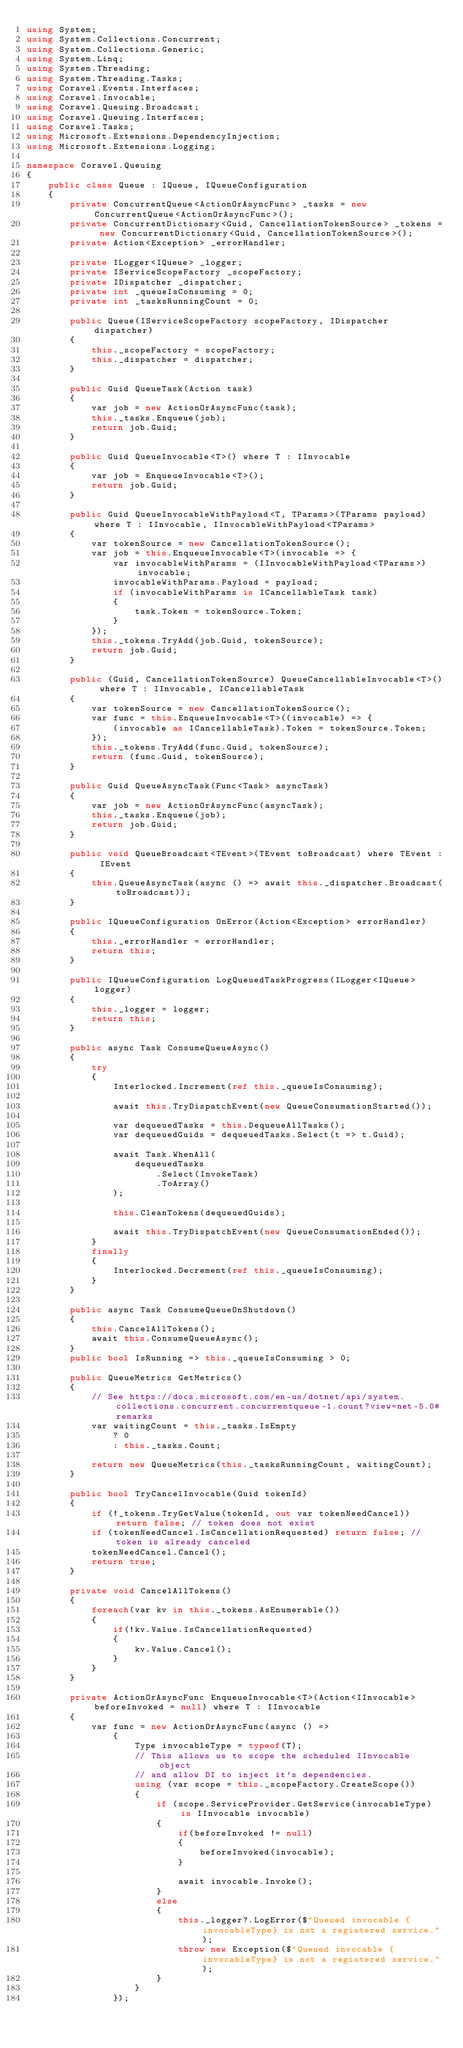Convert code to text. <code><loc_0><loc_0><loc_500><loc_500><_C#_>using System;
using System.Collections.Concurrent;
using System.Collections.Generic;
using System.Linq;
using System.Threading;
using System.Threading.Tasks;
using Coravel.Events.Interfaces;
using Coravel.Invocable;
using Coravel.Queuing.Broadcast;
using Coravel.Queuing.Interfaces;
using Coravel.Tasks;
using Microsoft.Extensions.DependencyInjection;
using Microsoft.Extensions.Logging;

namespace Coravel.Queuing
{
    public class Queue : IQueue, IQueueConfiguration
    {
        private ConcurrentQueue<ActionOrAsyncFunc> _tasks = new ConcurrentQueue<ActionOrAsyncFunc>();
        private ConcurrentDictionary<Guid, CancellationTokenSource> _tokens = new ConcurrentDictionary<Guid, CancellationTokenSource>();
        private Action<Exception> _errorHandler;

        private ILogger<IQueue> _logger;
        private IServiceScopeFactory _scopeFactory;
        private IDispatcher _dispatcher;
        private int _queueIsConsuming = 0;
        private int _tasksRunningCount = 0;

        public Queue(IServiceScopeFactory scopeFactory, IDispatcher dispatcher)
        {
            this._scopeFactory = scopeFactory;
            this._dispatcher = dispatcher;
        }

        public Guid QueueTask(Action task)
        {
            var job = new ActionOrAsyncFunc(task);
            this._tasks.Enqueue(job);
            return job.Guid;
        }

        public Guid QueueInvocable<T>() where T : IInvocable
        {
            var job = EnqueueInvocable<T>();
            return job.Guid;
        }

        public Guid QueueInvocableWithPayload<T, TParams>(TParams payload) where T : IInvocable, IInvocableWithPayload<TParams>
        {
            var tokenSource = new CancellationTokenSource();
            var job = this.EnqueueInvocable<T>(invocable => {
                var invocableWithParams = (IInvocableWithPayload<TParams>) invocable;
                invocableWithParams.Payload = payload;
                if (invocableWithParams is ICancellableTask task)
                {
                    task.Token = tokenSource.Token;
                }
            });
            this._tokens.TryAdd(job.Guid, tokenSource);
            return job.Guid;
        }

        public (Guid, CancellationTokenSource) QueueCancellableInvocable<T>() where T : IInvocable, ICancellableTask
        {
            var tokenSource = new CancellationTokenSource();
            var func = this.EnqueueInvocable<T>((invocable) => {
                (invocable as ICancellableTask).Token = tokenSource.Token;
            });
            this._tokens.TryAdd(func.Guid, tokenSource);
            return (func.Guid, tokenSource);
        }

        public Guid QueueAsyncTask(Func<Task> asyncTask)
        {
            var job = new ActionOrAsyncFunc(asyncTask);
            this._tasks.Enqueue(job);
            return job.Guid;
        }

        public void QueueBroadcast<TEvent>(TEvent toBroadcast) where TEvent : IEvent
        {
            this.QueueAsyncTask(async () => await this._dispatcher.Broadcast(toBroadcast));
        }

        public IQueueConfiguration OnError(Action<Exception> errorHandler)
        {
            this._errorHandler = errorHandler;
            return this;
        }

        public IQueueConfiguration LogQueuedTaskProgress(ILogger<IQueue> logger)
        {
            this._logger = logger;
            return this;
        }

        public async Task ConsumeQueueAsync()
        {
            try
            {
                Interlocked.Increment(ref this._queueIsConsuming);

                await this.TryDispatchEvent(new QueueConsumationStarted());

                var dequeuedTasks = this.DequeueAllTasks();
                var dequeuedGuids = dequeuedTasks.Select(t => t.Guid);

                await Task.WhenAll(
                    dequeuedTasks
                        .Select(InvokeTask)
                        .ToArray()
                );

                this.CleanTokens(dequeuedGuids);

                await this.TryDispatchEvent(new QueueConsumationEnded());
            }
            finally
            {
                Interlocked.Decrement(ref this._queueIsConsuming);
            }
        }

        public async Task ConsumeQueueOnShutdown() 
        {
            this.CancelAllTokens();
            await this.ConsumeQueueAsync();
        }
        public bool IsRunning => this._queueIsConsuming > 0;

        public QueueMetrics GetMetrics()
        {
            // See https://docs.microsoft.com/en-us/dotnet/api/system.collections.concurrent.concurrentqueue-1.count?view=net-5.0#remarks
            var waitingCount = this._tasks.IsEmpty
                ? 0
                : this._tasks.Count;

            return new QueueMetrics(this._tasksRunningCount, waitingCount);
        }

        public bool TryCancelInvocable(Guid tokenId)
        {
            if (!_tokens.TryGetValue(tokenId, out var tokenNeedCancel)) return false; // token does not exist
            if (tokenNeedCancel.IsCancellationRequested) return false; // token is already canceled
            tokenNeedCancel.Cancel();
            return true;
        }

        private void CancelAllTokens()
        {
            foreach(var kv in this._tokens.AsEnumerable())
            {
                if(!kv.Value.IsCancellationRequested)
                {
                    kv.Value.Cancel();
                }
            }
        }

        private ActionOrAsyncFunc EnqueueInvocable<T>(Action<IInvocable> beforeInvoked = null) where T : IInvocable
        {
            var func = new ActionOrAsyncFunc(async () =>
                {
                    Type invocableType = typeof(T);
                    // This allows us to scope the scheduled IInvocable object
                    // and allow DI to inject it's dependencies.
                    using (var scope = this._scopeFactory.CreateScope())
                    {
                        if (scope.ServiceProvider.GetService(invocableType) is IInvocable invocable)
                        {                            
                            if(beforeInvoked != null)
                            {                            
                                beforeInvoked(invocable);
                            }

                            await invocable.Invoke();
                        }
                        else
                        {
                            this._logger?.LogError($"Queued invocable {invocableType} is not a registered service.");
                            throw new Exception($"Queued invocable {invocableType} is not a registered service.");
                        }
                    }
                });</code> 